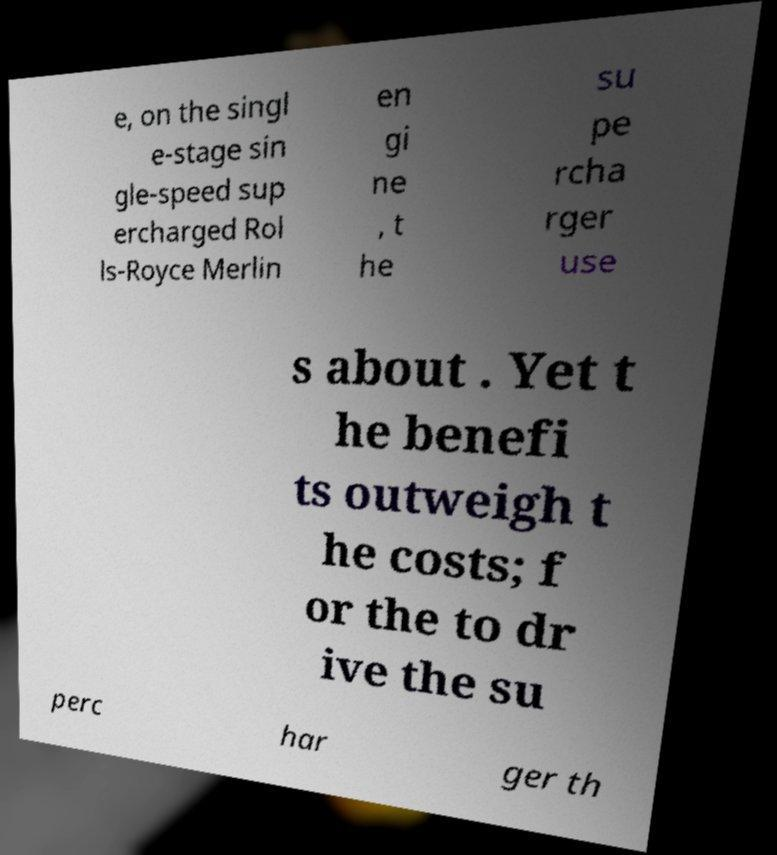Could you assist in decoding the text presented in this image and type it out clearly? e, on the singl e-stage sin gle-speed sup ercharged Rol ls-Royce Merlin en gi ne , t he su pe rcha rger use s about . Yet t he benefi ts outweigh t he costs; f or the to dr ive the su perc har ger th 